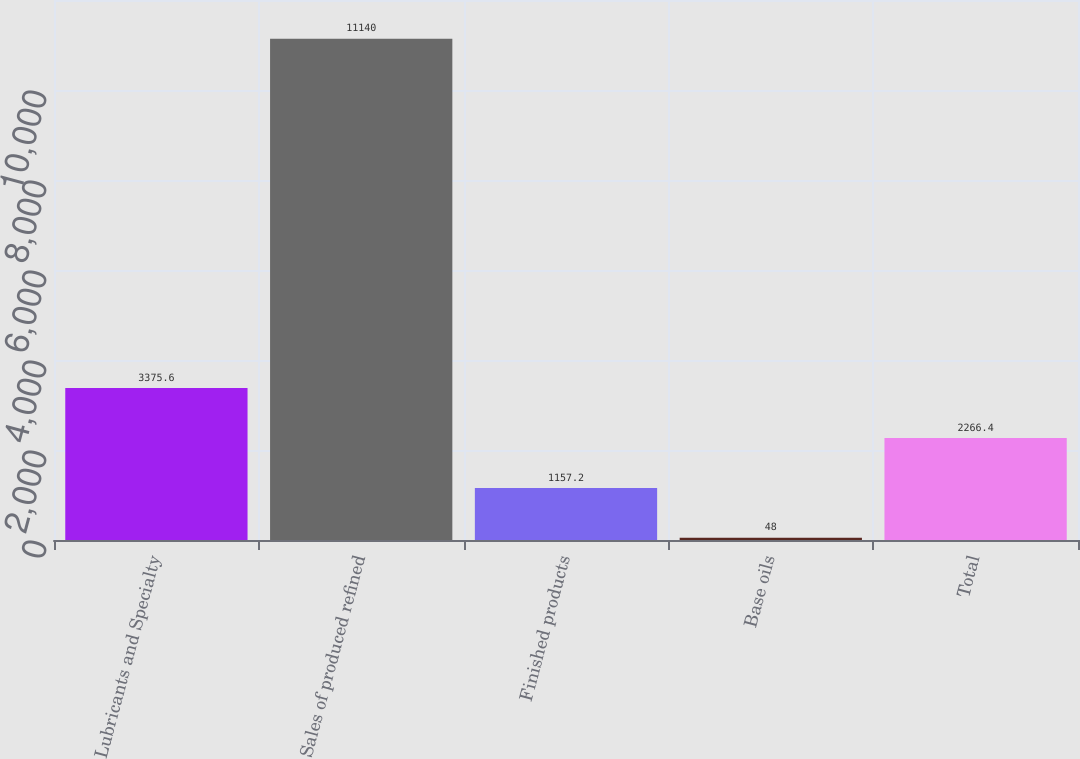Convert chart to OTSL. <chart><loc_0><loc_0><loc_500><loc_500><bar_chart><fcel>Lubricants and Specialty<fcel>Sales of produced refined<fcel>Finished products<fcel>Base oils<fcel>Total<nl><fcel>3375.6<fcel>11140<fcel>1157.2<fcel>48<fcel>2266.4<nl></chart> 